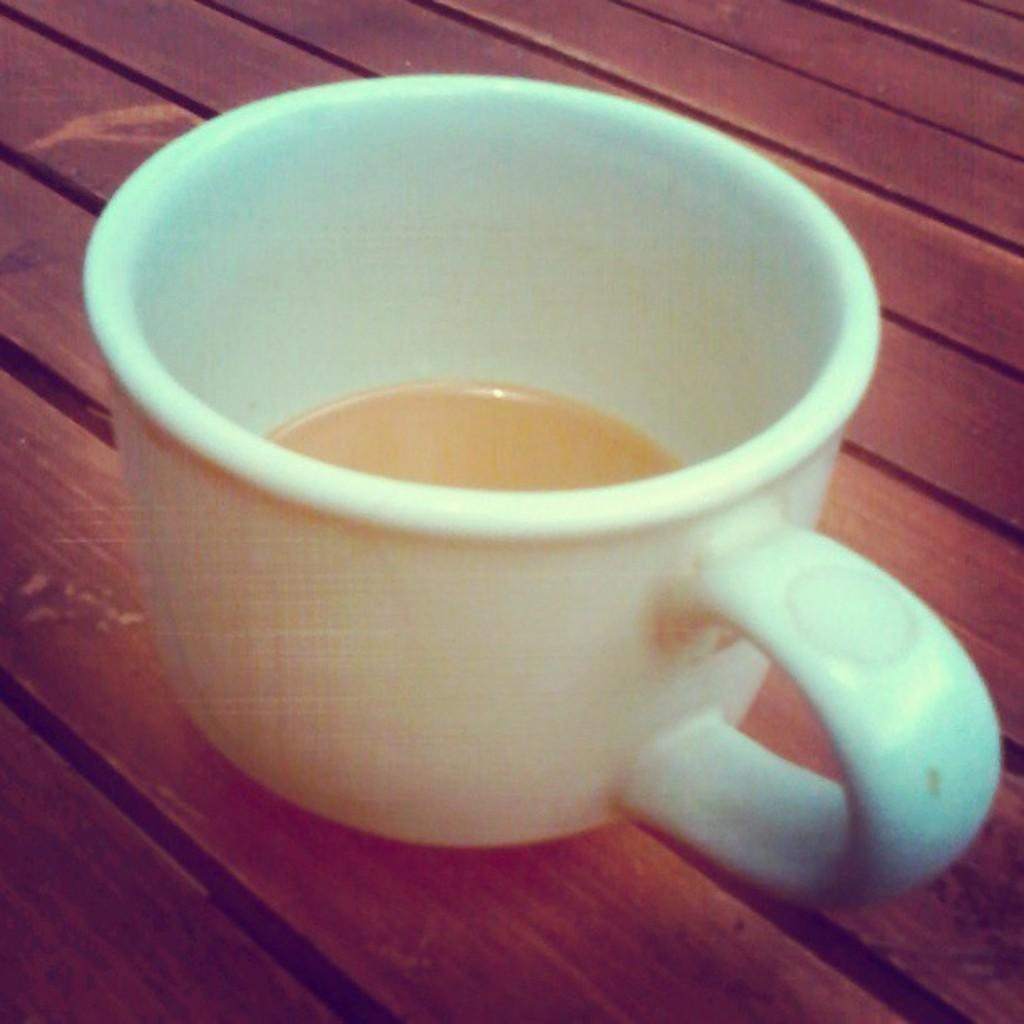What is the color of the cup that is visible in the image? The cup is white in color. What is inside the cup in the image? The cup contains a drink. What type of surface is the cup placed on in the image? The cup is placed on a wooden surface. Can you see any butter on the wooden surface in the image? There is no butter present on the wooden surface in the image. Is there an owl perched on the cup in the image? There is no owl present on the cup or in the image. 